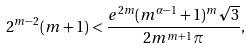Convert formula to latex. <formula><loc_0><loc_0><loc_500><loc_500>2 ^ { m - 2 } ( m + 1 ) < \frac { e ^ { 2 m } ( m ^ { \alpha - 1 } + 1 ) ^ { m } \sqrt { 3 } } { 2 m ^ { m + 1 } \pi } ,</formula> 